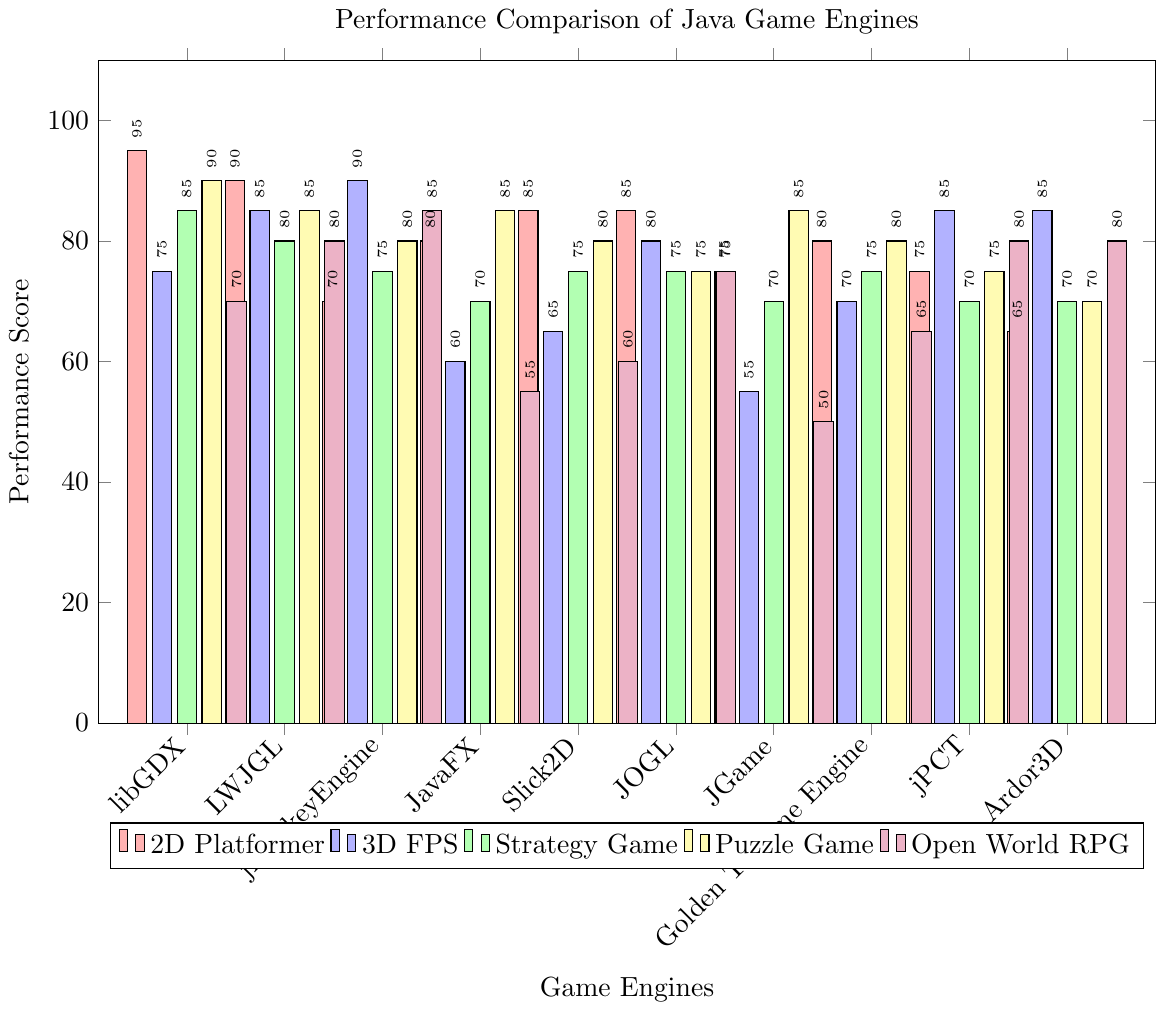Which game engine performs the best for 2D Platformer? Look at the heights of the red bars, which represent the performance score for 2D Platformer. The highest red bar corresponds to libGDX.
Answer: libGDX Which game engine has the lowest performance score for Open World RPG? Look at the heights of the purple bars, which represent the performance score for Open World RPG. The shortest purple bar corresponds to JGame.
Answer: JGame Compare the performance of libGDX and jMonkeyEngine for 3D FPS. Which one performs better? Look at the heights of the blue bars for libGDX and jMonkeyEngine, which represent the performance score for 3D FPS. libGDX has a score of 75, while jMonkeyEngine has a score of 90. Therefore, jMonkeyEngine performs better.
Answer: jMonkeyEngine What is the average performance score of JavaFX for all game types? Sum the performance scores for JavaFX across all game types and divide by the total number of game types. (80 + 60 + 70 + 85 + 55) = 350, and 350 / 5 = 70.
Answer: 70 Which game engine shows the most consistent performance across all game types? To determine consistency, look for the engine with the smallest range in performance scores. Calculate the difference between the highest and lowest performance scores for each engine. JOGL has scores of 85, 80, 75, 75, and 75; the range is 85 - 75 = 10.
Answer: JOGL What is the total performance score of LWJGL for all game types? Sum the performance scores for LWJGL across all game types: (90 + 85 + 80 + 85 + 80) = 420.
Answer: 420 Which game engine performs the worst for 3D FPS? Look at the heights of the blue bars, which represent the performance score for 3D FPS. The shortest blue bar corresponds to JGame.
Answer: JGame What is the difference between the highest and lowest performance scores for jPCT? Identify the highest and lowest scores for jPCT across all game types, then calculate the difference. The highest score is 85 (3D FPS), and the lowest score is 70 (2D Platformer and Strategy Game). The difference is 85 - 70 = 15.
Answer: 15 Which game type has the most significant variation in performance scores across all engines? Calculate the range of performance scores for each game type across all engines. Comparing these ranges: 2D Platformer (95 - 65 = 30), 3D FPS (90 - 55 = 35), Strategy Game (85 - 70 = 15), Puzzle Game (90 - 70 = 20), Open World RPG (80 - 50 = 30), the 3D FPS game type has the most significant variation.
Answer: 3D FPS For which game type does Slick2D have the highest performance score? Look for the highest bar among the bars representing Slick2D across all game types. Slick2D's highest score is 85, which is for 2D Platformer.
Answer: 2D Platformer 